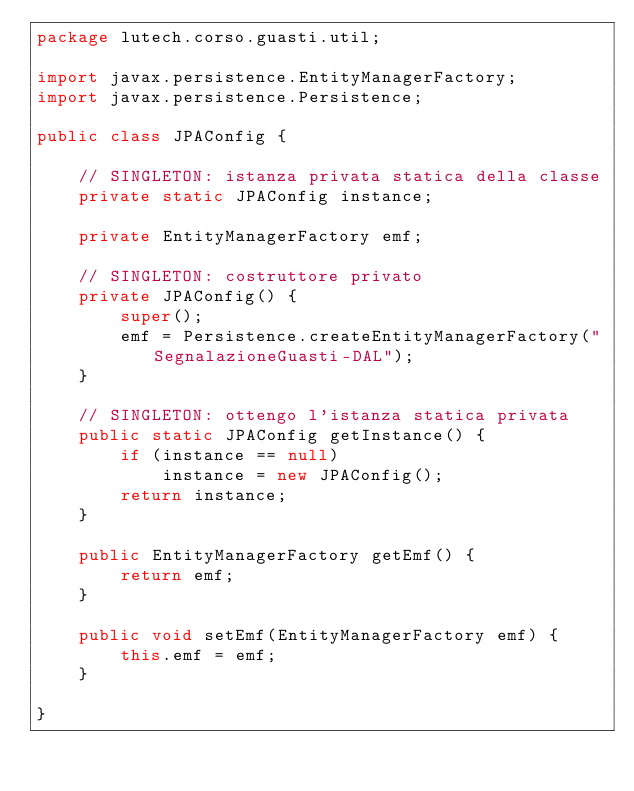Convert code to text. <code><loc_0><loc_0><loc_500><loc_500><_Java_>package lutech.corso.guasti.util;

import javax.persistence.EntityManagerFactory;
import javax.persistence.Persistence;

public class JPAConfig {

	// SINGLETON: istanza privata statica della classe
	private static JPAConfig instance;

	private EntityManagerFactory emf;
	
	// SINGLETON: costruttore privato
	private JPAConfig() {
		super();
		emf = Persistence.createEntityManagerFactory("SegnalazioneGuasti-DAL");
	}
	
	// SINGLETON: ottengo l'istanza statica privata
	public static JPAConfig getInstance() {
		if (instance == null)
			instance = new JPAConfig();
		return instance;
	}
	
	public EntityManagerFactory getEmf() {
		return emf;
	}

	public void setEmf(EntityManagerFactory emf) {
		this.emf = emf;
	}	

}
</code> 